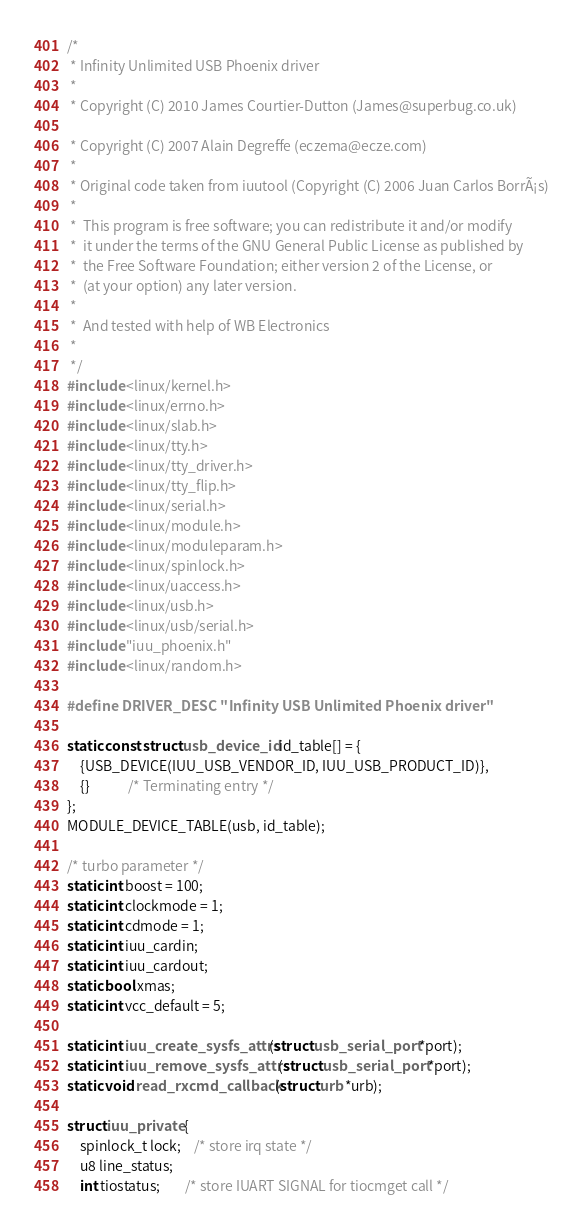<code> <loc_0><loc_0><loc_500><loc_500><_C_>/*
 * Infinity Unlimited USB Phoenix driver
 *
 * Copyright (C) 2010 James Courtier-Dutton (James@superbug.co.uk)

 * Copyright (C) 2007 Alain Degreffe (eczema@ecze.com)
 *
 * Original code taken from iuutool (Copyright (C) 2006 Juan Carlos BorrÃ¡s)
 *
 *	This program is free software; you can redistribute it and/or modify
 *	it under the terms of the GNU General Public License as published by
 *	the Free Software Foundation; either version 2 of the License, or
 *	(at your option) any later version.
 *
 *  And tested with help of WB Electronics
 *
 */
#include <linux/kernel.h>
#include <linux/errno.h>
#include <linux/slab.h>
#include <linux/tty.h>
#include <linux/tty_driver.h>
#include <linux/tty_flip.h>
#include <linux/serial.h>
#include <linux/module.h>
#include <linux/moduleparam.h>
#include <linux/spinlock.h>
#include <linux/uaccess.h>
#include <linux/usb.h>
#include <linux/usb/serial.h>
#include "iuu_phoenix.h"
#include <linux/random.h>

#define DRIVER_DESC "Infinity USB Unlimited Phoenix driver"

static const struct usb_device_id id_table[] = {
	{USB_DEVICE(IUU_USB_VENDOR_ID, IUU_USB_PRODUCT_ID)},
	{}			/* Terminating entry */
};
MODULE_DEVICE_TABLE(usb, id_table);

/* turbo parameter */
static int boost = 100;
static int clockmode = 1;
static int cdmode = 1;
static int iuu_cardin;
static int iuu_cardout;
static bool xmas;
static int vcc_default = 5;

static int iuu_create_sysfs_attrs(struct usb_serial_port *port);
static int iuu_remove_sysfs_attrs(struct usb_serial_port *port);
static void read_rxcmd_callback(struct urb *urb);

struct iuu_private {
	spinlock_t lock;	/* store irq state */
	u8 line_status;
	int tiostatus;		/* store IUART SIGNAL for tiocmget call */</code> 